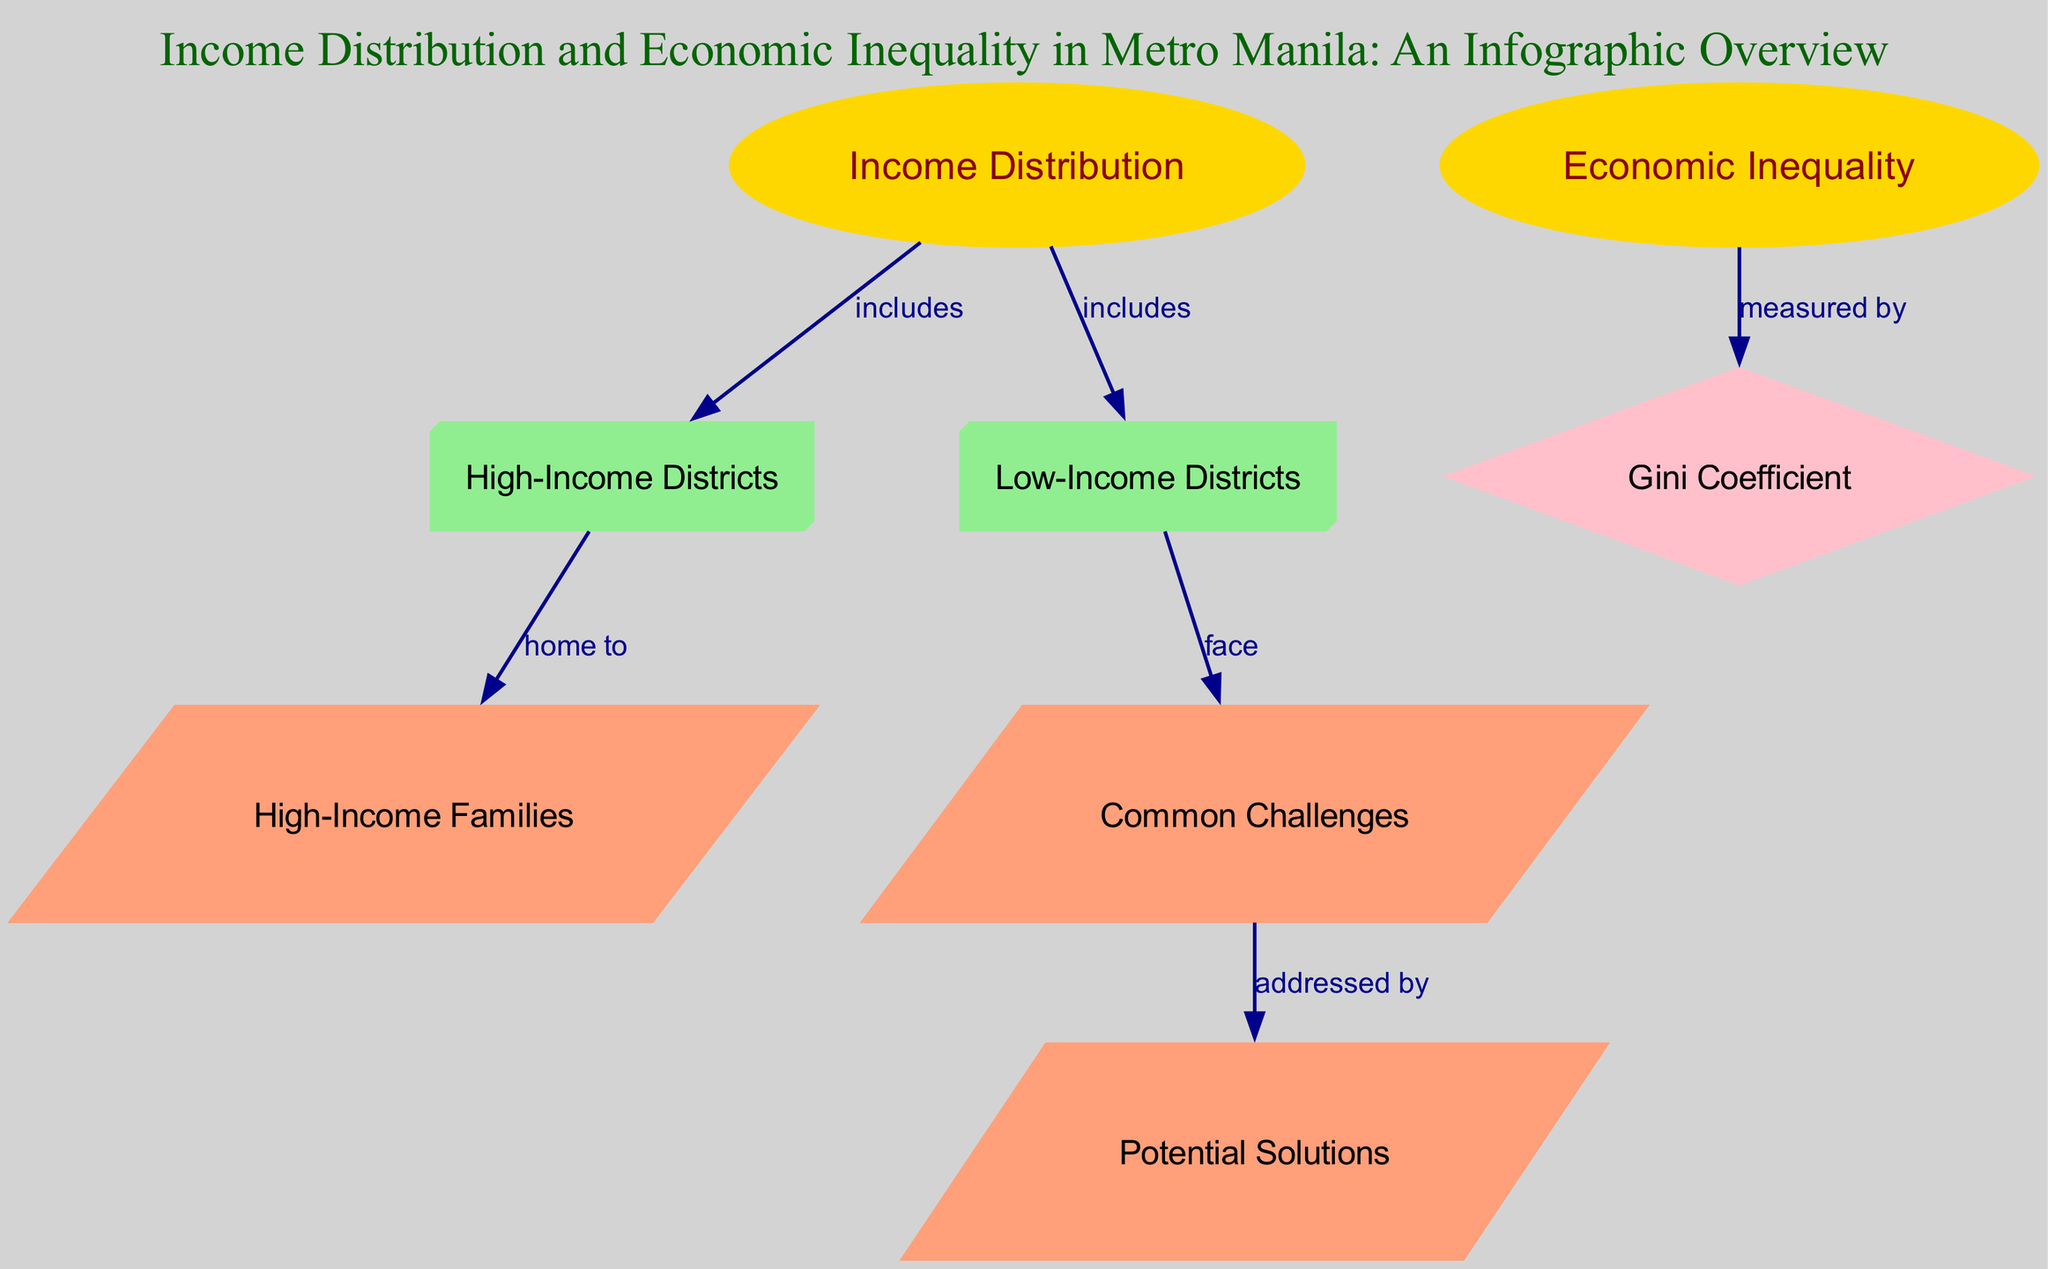What are the two main categories of income levels in Metro Manila? The diagram includes two nodes that represent distinct income levels: one for high-income districts and another for low-income districts, indicating that these are the primary categories discussed in the infographic.
Answer: High-Income Districts and Low-Income Districts How is economic inequality measured in the diagram? The diagram directly connects the node for economic inequality to the Gini coefficient node, indicating that the Gini coefficient is the method used to measure economic inequality in Metro Manila.
Answer: Gini Coefficient What type of families reside in high-income districts? The diagram reveals that high-income districts are home to high-income families through a directed edge that connects these two nodes, indicating the relationship.
Answer: High-Income Families What challenges do low-income districts face? According to the diagram, low-income districts are linked to a node that describes common challenges, suggesting that these districts experience difficulties that are addressed in a subsequent node.
Answer: Common Challenges Which node specifies potential solutions to common challenges? The diagram links the node for common challenges to the node for potential solutions, indicating that this node outlines the approaches or strategies to address the issues faced in low-income districts.
Answer: Potential Solutions What does the Gini coefficient indicate in terms of economic inequality? The diagram illustrates that the Gini coefficient serves as a measure for economic inequality, providing a quantitative method for calculating the level of inequality present within income distribution in Metro Manila.
Answer: Measures Economic Inequality How many edges connect 'Income Distribution' to other nodes? By examining the diagram, one can count three edges extending from the 'Income Distribution' node, demonstrating that it has significant connections to high-income and low-income districts.
Answer: 3 